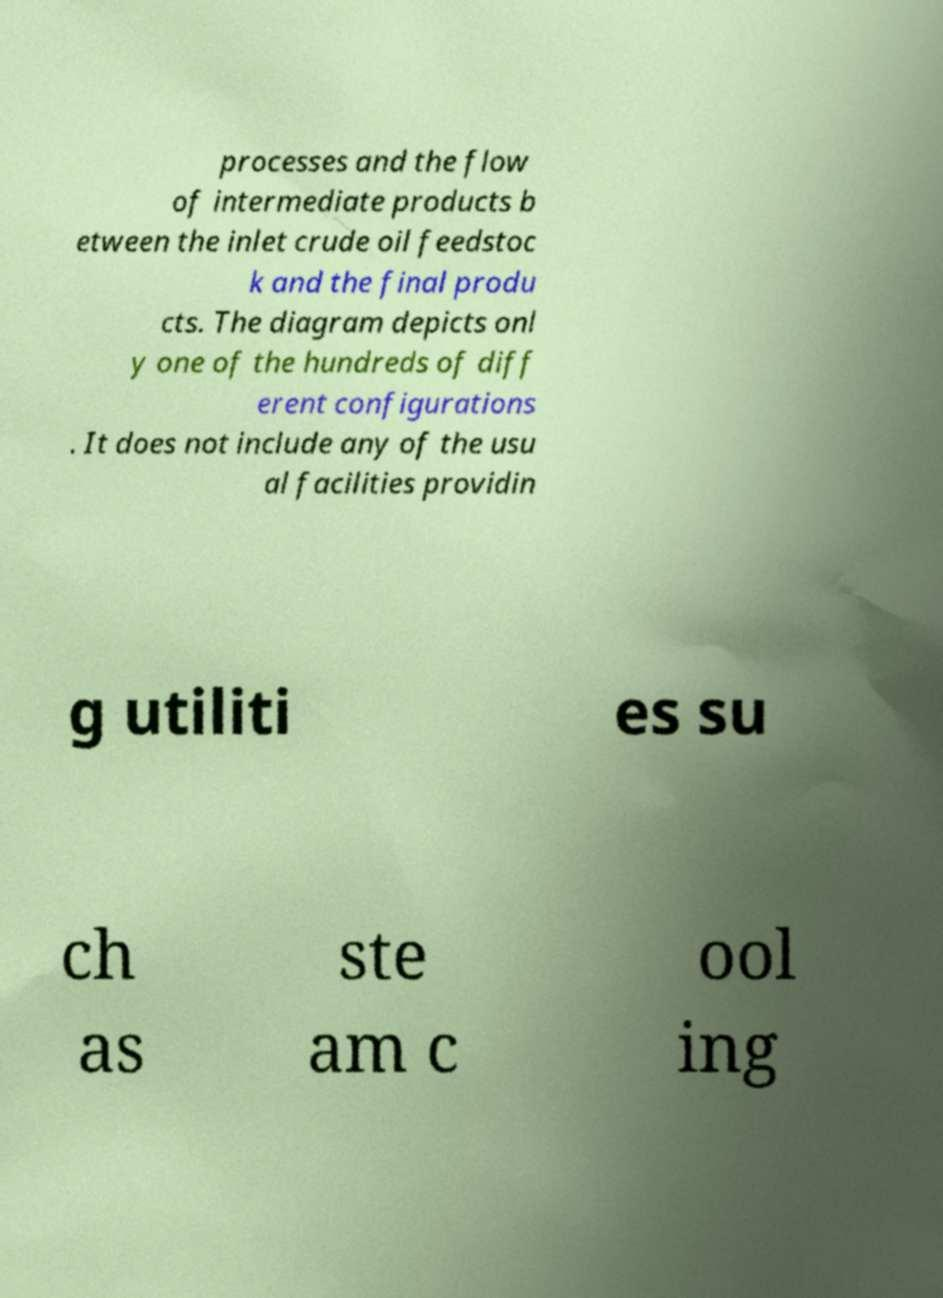Please identify and transcribe the text found in this image. processes and the flow of intermediate products b etween the inlet crude oil feedstoc k and the final produ cts. The diagram depicts onl y one of the hundreds of diff erent configurations . It does not include any of the usu al facilities providin g utiliti es su ch as ste am c ool ing 